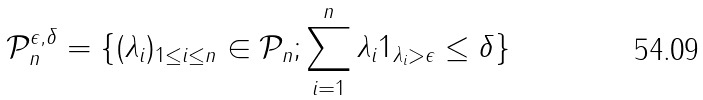Convert formula to latex. <formula><loc_0><loc_0><loc_500><loc_500>\mathcal { P } _ { n } ^ { \epsilon , \delta } = \{ ( \lambda _ { i } ) _ { 1 \leq i \leq n } \in \mathcal { P } _ { n } ; \sum _ { i = 1 } ^ { n } \lambda _ { i } 1 _ { \lambda _ { i } > \epsilon } \leq \delta \}</formula> 